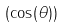Convert formula to latex. <formula><loc_0><loc_0><loc_500><loc_500>( \cos ( \theta ) )</formula> 